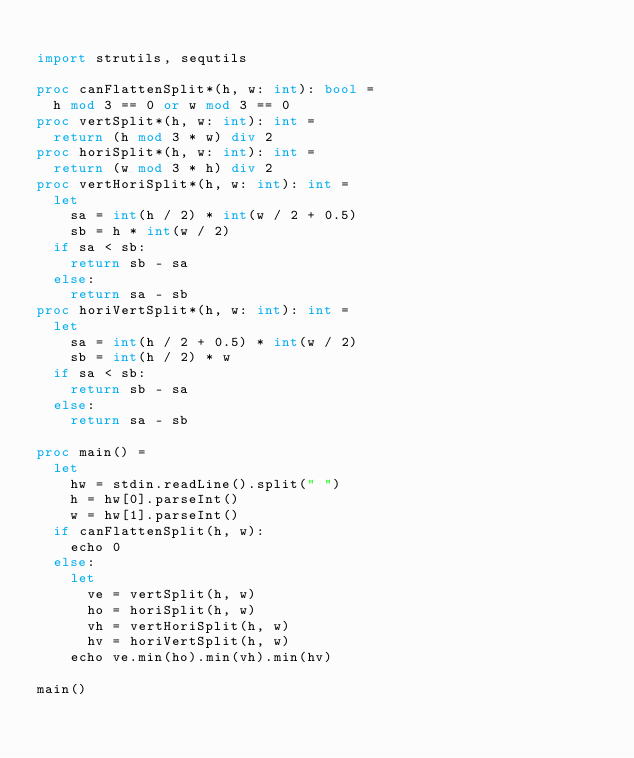Convert code to text. <code><loc_0><loc_0><loc_500><loc_500><_Nim_>
import strutils, sequtils

proc canFlattenSplit*(h, w: int): bool =
  h mod 3 == 0 or w mod 3 == 0
proc vertSplit*(h, w: int): int =
  return (h mod 3 * w) div 2
proc horiSplit*(h, w: int): int =
  return (w mod 3 * h) div 2
proc vertHoriSplit*(h, w: int): int =
  let
    sa = int(h / 2) * int(w / 2 + 0.5)
    sb = h * int(w / 2)
  if sa < sb:
    return sb - sa
  else:
    return sa - sb
proc horiVertSplit*(h, w: int): int =
  let
    sa = int(h / 2 + 0.5) * int(w / 2)
    sb = int(h / 2) * w
  if sa < sb:
    return sb - sa
  else:
    return sa - sb

proc main() =
  let
    hw = stdin.readLine().split(" ")
    h = hw[0].parseInt()
    w = hw[1].parseInt()
  if canFlattenSplit(h, w):
    echo 0
  else:
    let
      ve = vertSplit(h, w)
      ho = horiSplit(h, w)
      vh = vertHoriSplit(h, w)
      hv = horiVertSplit(h, w)
    echo ve.min(ho).min(vh).min(hv)

main()
</code> 